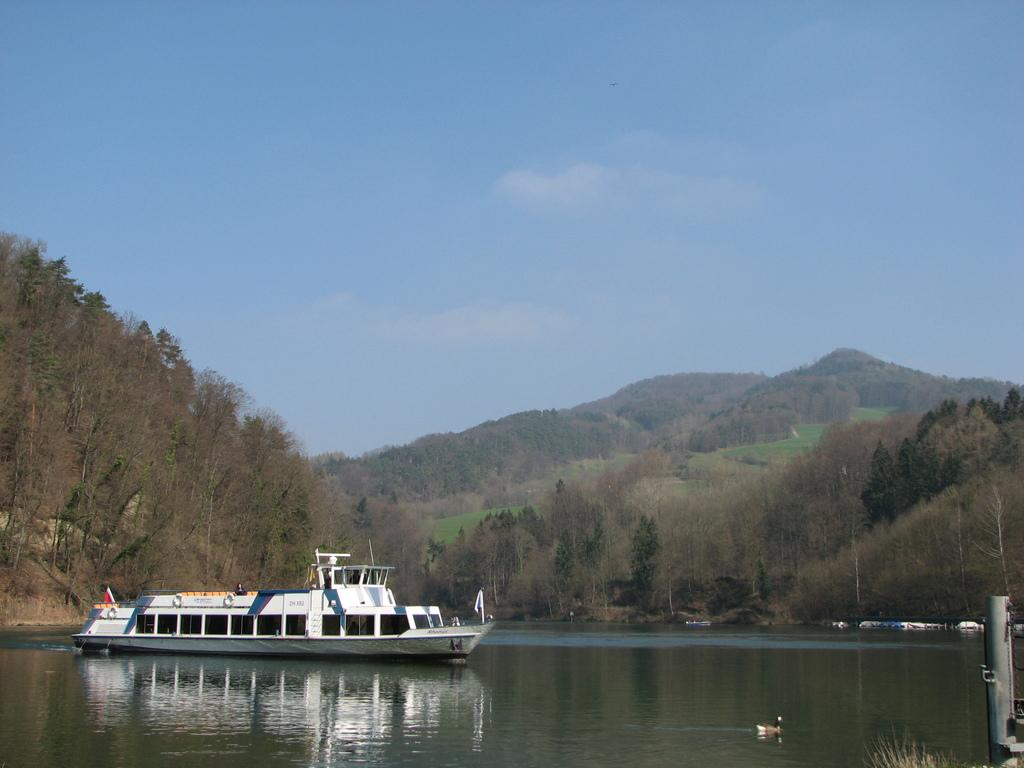What is the main subject of the image? The main subject of the image is a boat. What else can be seen on the water in the image? There is a bird on the water in the image. What type of landscape is visible in the background of the image? There are trees and hills in the background of the image. What is visible above the landscape in the image? The sky is visible in the background of the image. What type of spy equipment can be seen in the image? There is no spy equipment present in the image. How many quarters are visible on the boat in the image? There are no quarters visible in the image. 